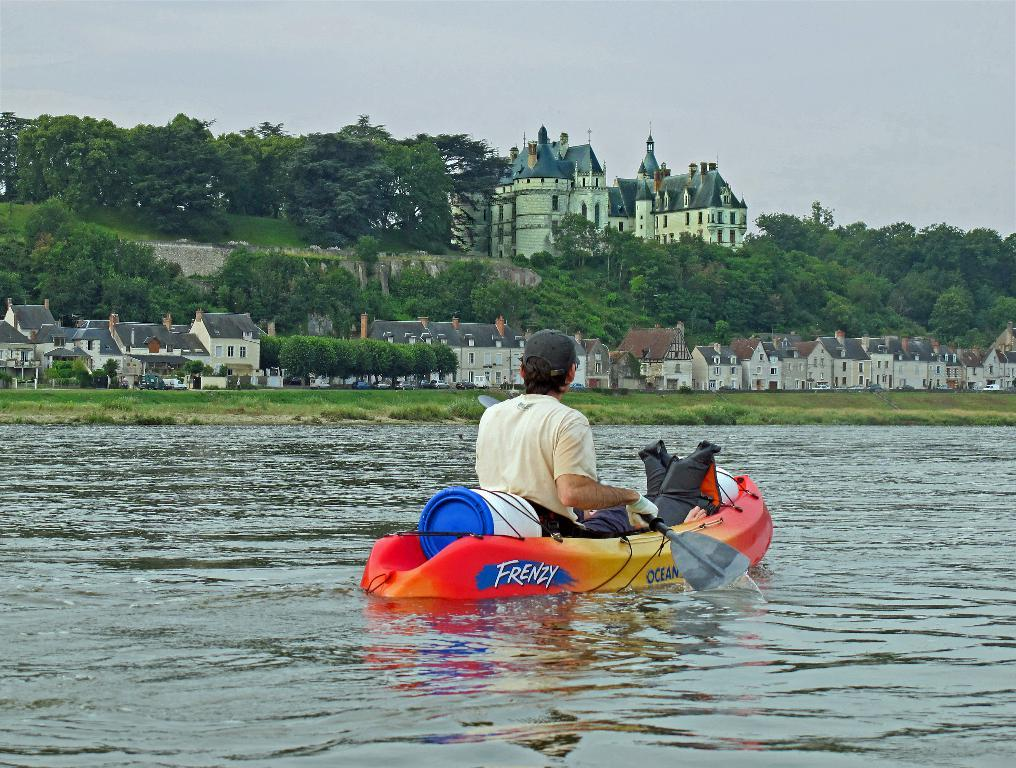What is the primary element present in the image? There is water in the image. What is the man in the image doing? The man is sitting on a fuel boat in the image. What type of structures can be seen in the image? There are houses and buildings in the image. What other natural elements are present in the image? There are trees in the image. What is visible in the background of the image? The sky is visible in the image. What type of maid can be seen in the image? There is no maid present in the image. What type of animal can be seen in the image? There is no animal present in the image. What type of appliance can be seen in the image? There is no appliance present in the image. 